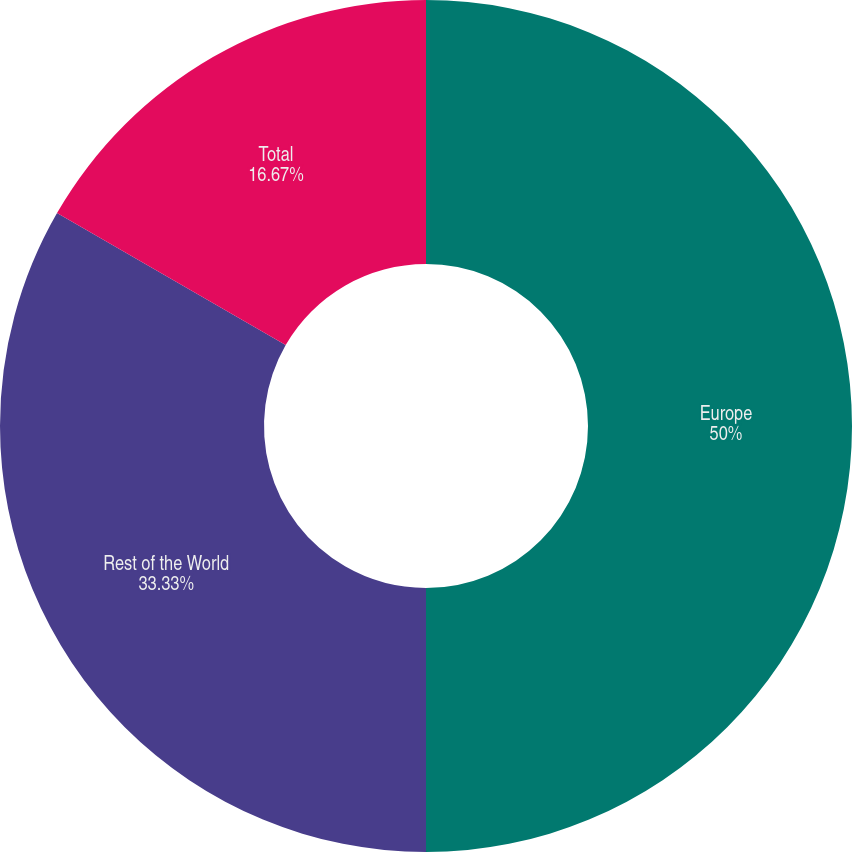Convert chart. <chart><loc_0><loc_0><loc_500><loc_500><pie_chart><fcel>Europe<fcel>Rest of the World<fcel>Total<nl><fcel>50.0%<fcel>33.33%<fcel>16.67%<nl></chart> 